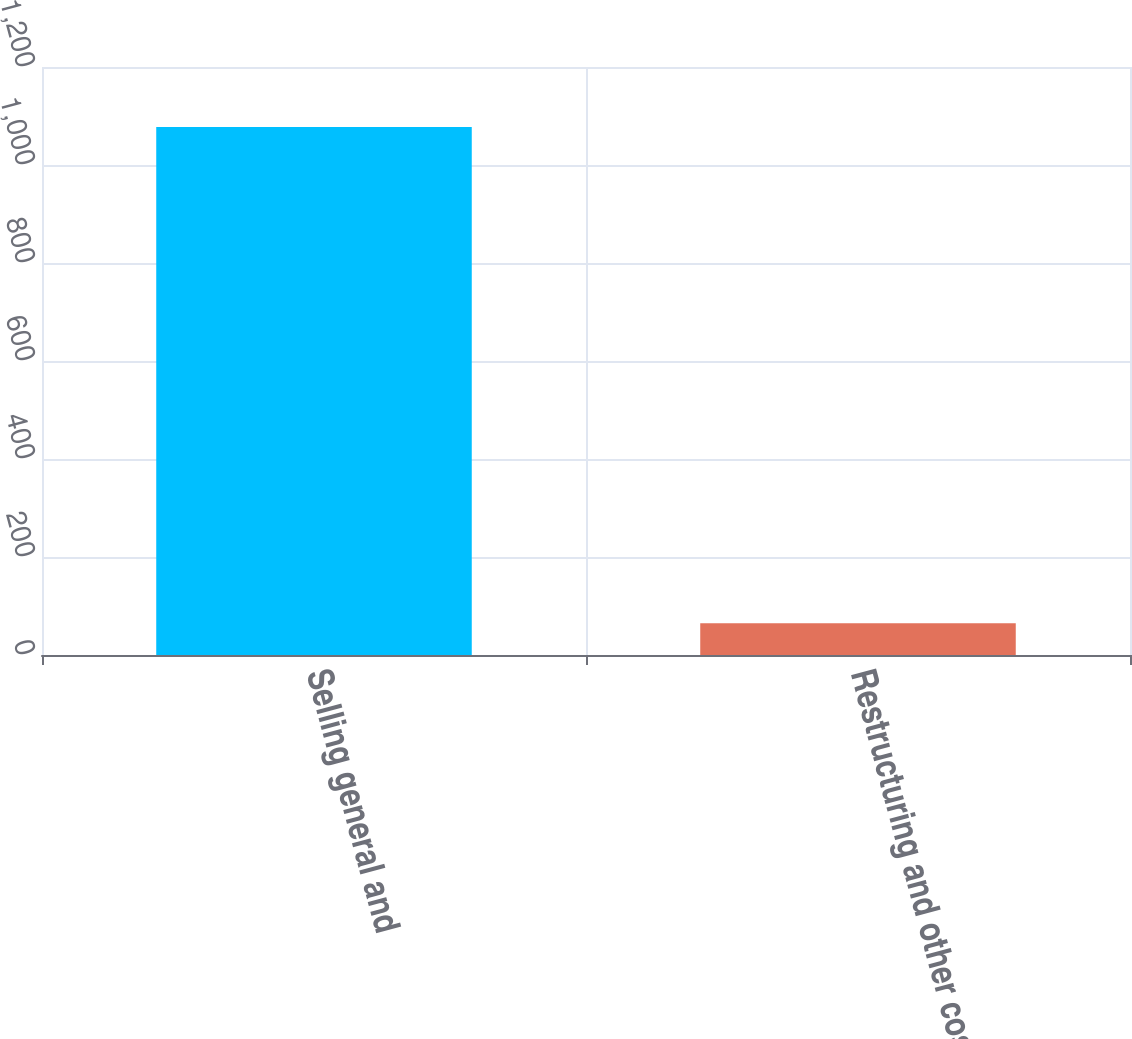<chart> <loc_0><loc_0><loc_500><loc_500><bar_chart><fcel>Selling general and<fcel>Restructuring and other costs<nl><fcel>1077.3<fcel>64.7<nl></chart> 